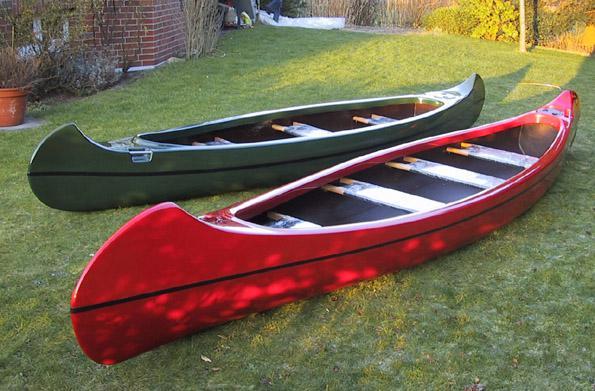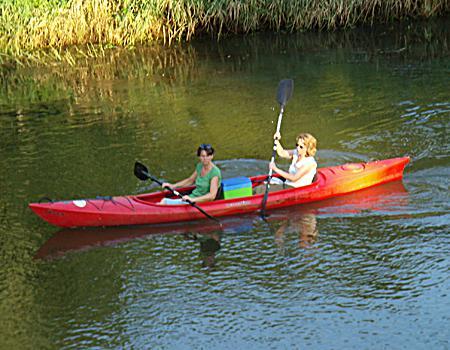The first image is the image on the left, the second image is the image on the right. For the images shown, is this caption "One of the images contain only one boat." true? Answer yes or no. Yes. The first image is the image on the left, the second image is the image on the right. Examine the images to the left and right. Is the description "An image shows a curving row of at least ten canoes, none containing humans." accurate? Answer yes or no. No. 